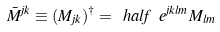<formula> <loc_0><loc_0><loc_500><loc_500>\bar { M } ^ { j k } \equiv ( M _ { j k } ) ^ { \dagger } = \ h a l f \ e ^ { j k l m } M _ { l m }</formula> 